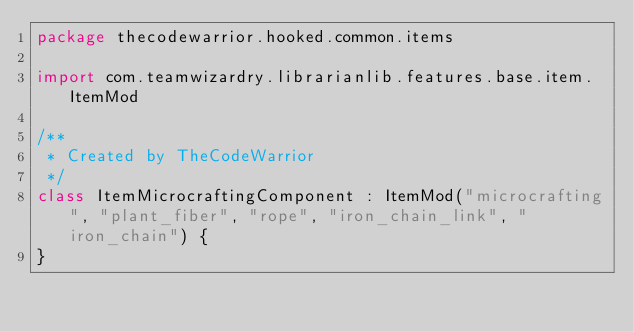<code> <loc_0><loc_0><loc_500><loc_500><_Kotlin_>package thecodewarrior.hooked.common.items

import com.teamwizardry.librarianlib.features.base.item.ItemMod

/**
 * Created by TheCodeWarrior
 */
class ItemMicrocraftingComponent : ItemMod("microcrafting", "plant_fiber", "rope", "iron_chain_link", "iron_chain") {
}
</code> 